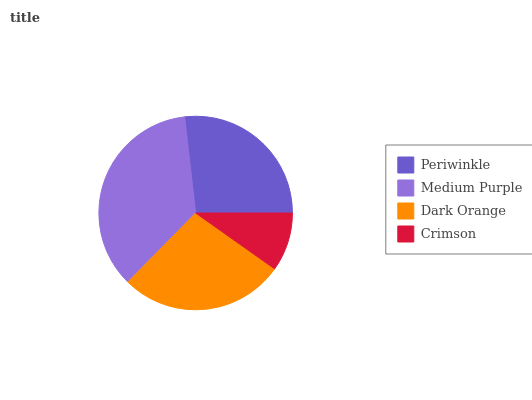Is Crimson the minimum?
Answer yes or no. Yes. Is Medium Purple the maximum?
Answer yes or no. Yes. Is Dark Orange the minimum?
Answer yes or no. No. Is Dark Orange the maximum?
Answer yes or no. No. Is Medium Purple greater than Dark Orange?
Answer yes or no. Yes. Is Dark Orange less than Medium Purple?
Answer yes or no. Yes. Is Dark Orange greater than Medium Purple?
Answer yes or no. No. Is Medium Purple less than Dark Orange?
Answer yes or no. No. Is Dark Orange the high median?
Answer yes or no. Yes. Is Periwinkle the low median?
Answer yes or no. Yes. Is Crimson the high median?
Answer yes or no. No. Is Dark Orange the low median?
Answer yes or no. No. 